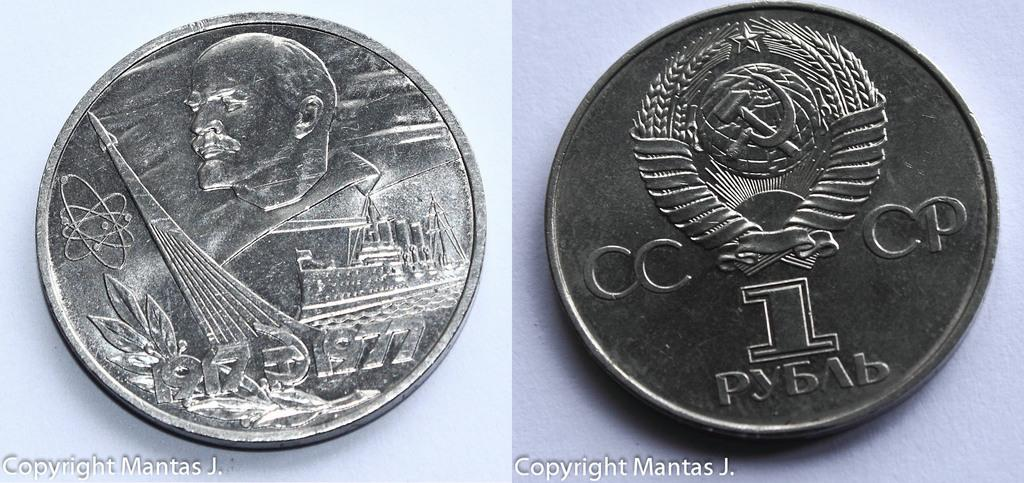<image>
Summarize the visual content of the image. Front and back of a silver 1 rouble Russian coin. 